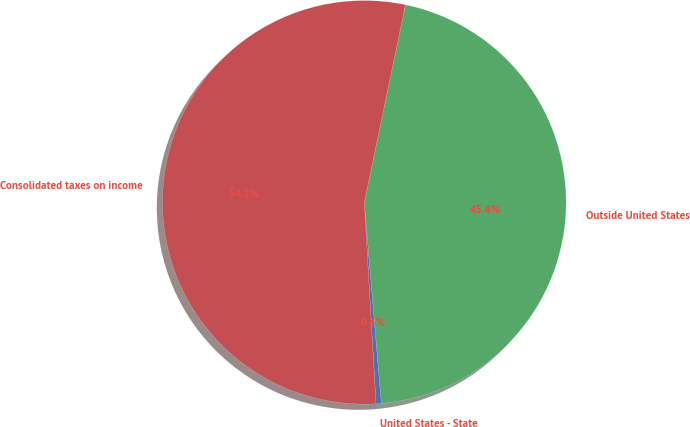<chart> <loc_0><loc_0><loc_500><loc_500><pie_chart><fcel>United States - State<fcel>Outside United States<fcel>Consolidated taxes on income<nl><fcel>0.43%<fcel>45.38%<fcel>54.19%<nl></chart> 